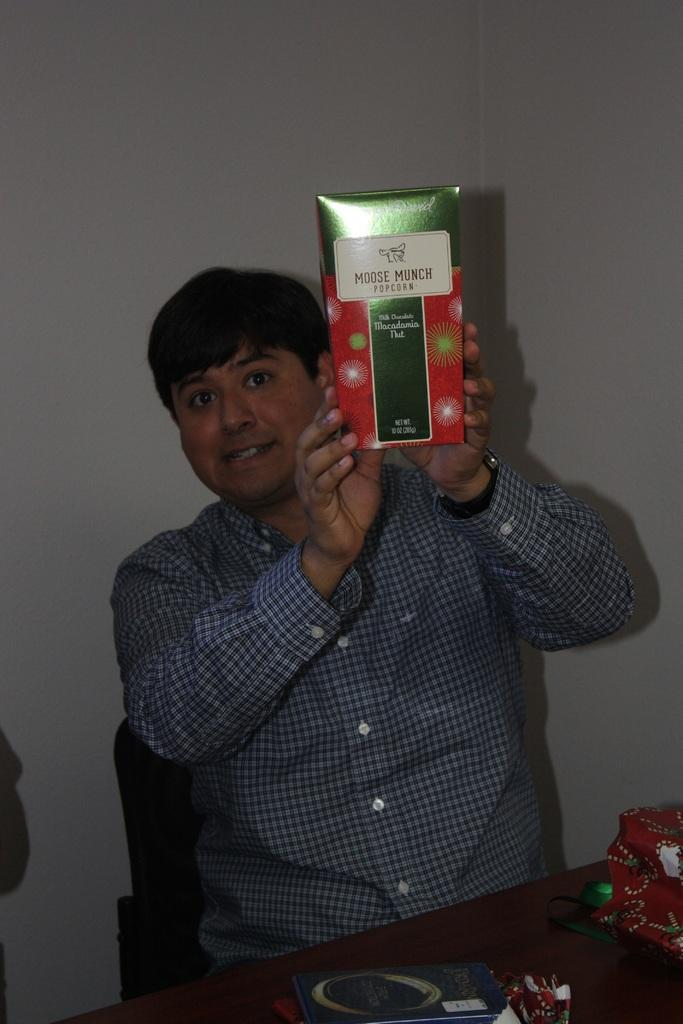<image>
Describe the image concisely. A man holds up a box of moose munch popcorn. 